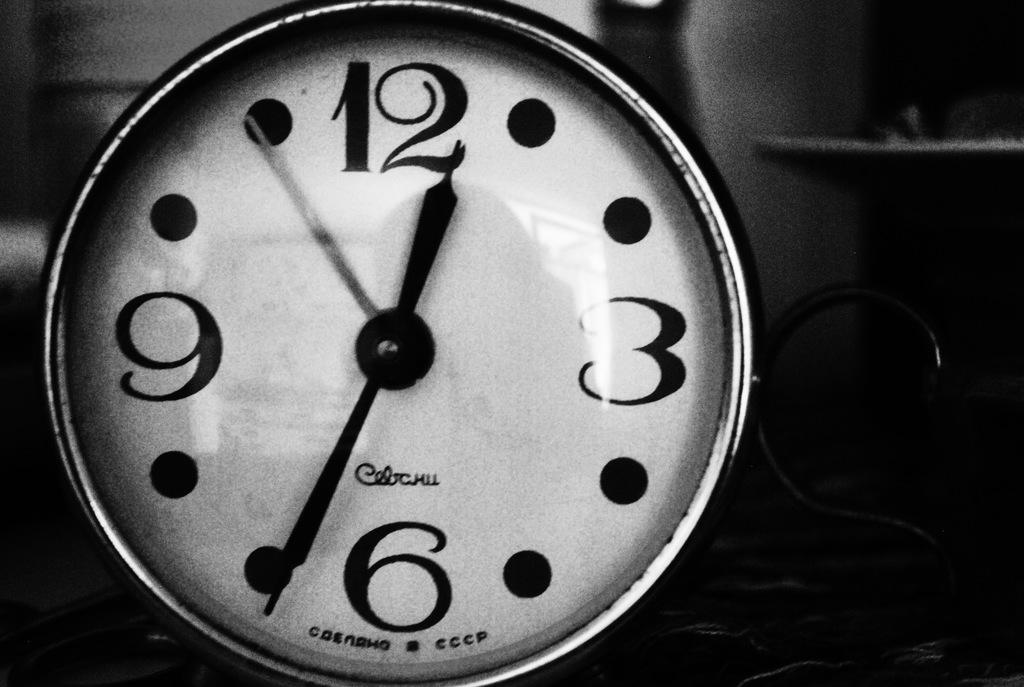What object can be seen in the image that is used for telling time? There is a clock in the image. What can be observed about the lighting or color of the background in the image? The background of the image is dark. What type of lettuce is being used to knit a mitten in the image? There is no lettuce or mitten present in the image. 